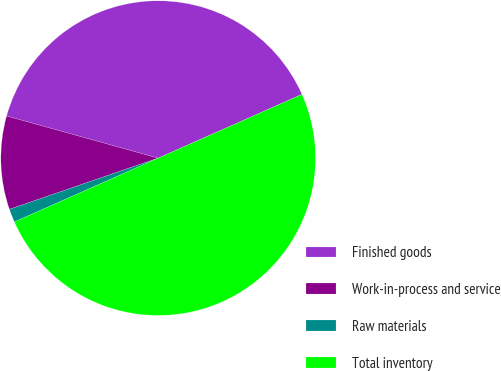Convert chart to OTSL. <chart><loc_0><loc_0><loc_500><loc_500><pie_chart><fcel>Finished goods<fcel>Work-in-process and service<fcel>Raw materials<fcel>Total inventory<nl><fcel>39.05%<fcel>9.59%<fcel>1.37%<fcel>50.0%<nl></chart> 